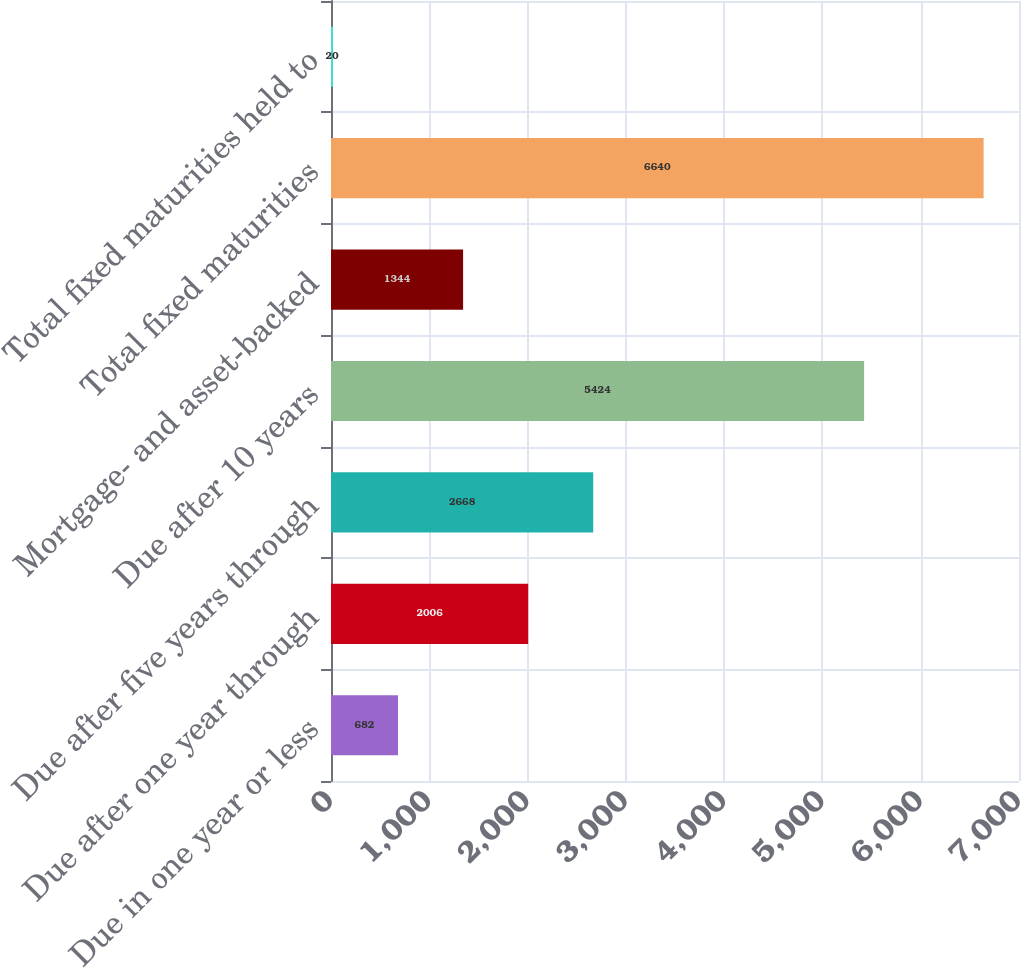Convert chart to OTSL. <chart><loc_0><loc_0><loc_500><loc_500><bar_chart><fcel>Due in one year or less<fcel>Due after one year through<fcel>Due after five years through<fcel>Due after 10 years<fcel>Mortgage- and asset-backed<fcel>Total fixed maturities<fcel>Total fixed maturities held to<nl><fcel>682<fcel>2006<fcel>2668<fcel>5424<fcel>1344<fcel>6640<fcel>20<nl></chart> 